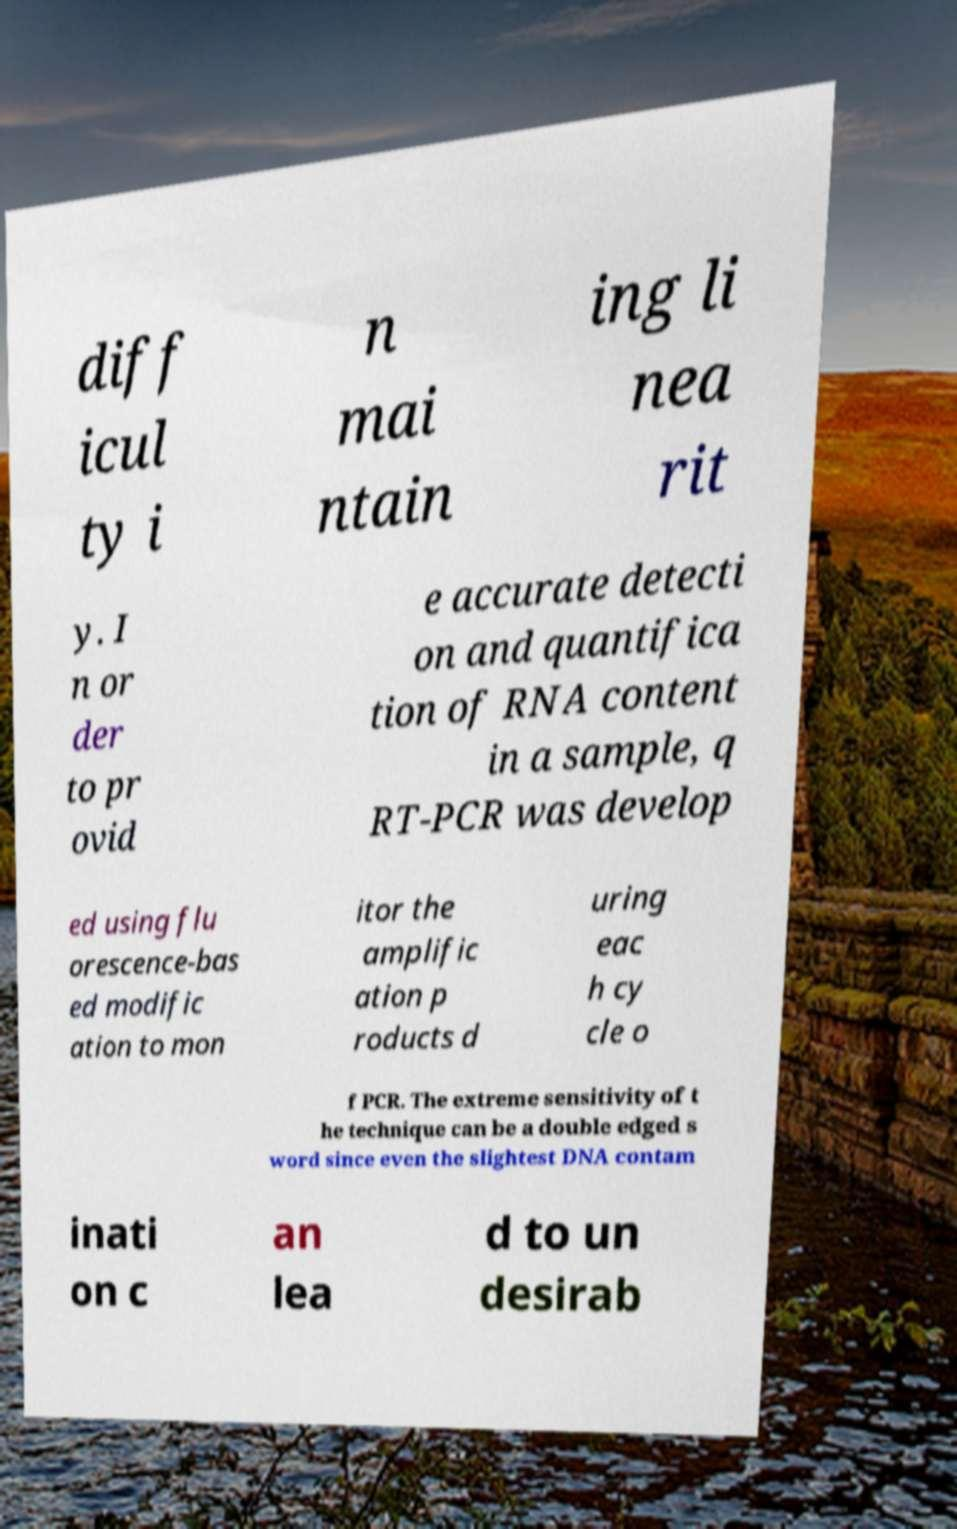I need the written content from this picture converted into text. Can you do that? diff icul ty i n mai ntain ing li nea rit y. I n or der to pr ovid e accurate detecti on and quantifica tion of RNA content in a sample, q RT-PCR was develop ed using flu orescence-bas ed modific ation to mon itor the amplific ation p roducts d uring eac h cy cle o f PCR. The extreme sensitivity of t he technique can be a double edged s word since even the slightest DNA contam inati on c an lea d to un desirab 